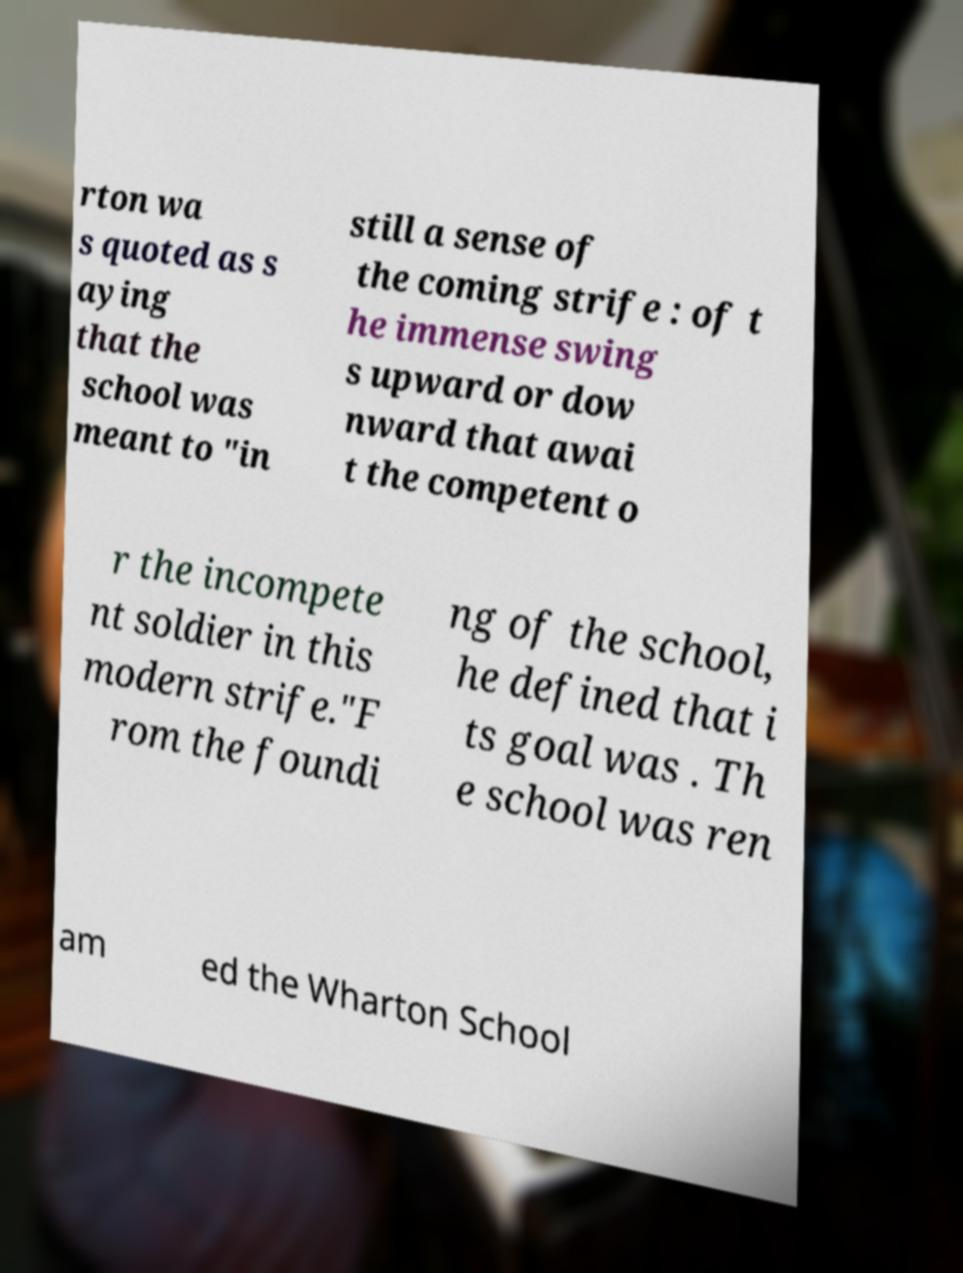Can you accurately transcribe the text from the provided image for me? rton wa s quoted as s aying that the school was meant to "in still a sense of the coming strife : of t he immense swing s upward or dow nward that awai t the competent o r the incompete nt soldier in this modern strife."F rom the foundi ng of the school, he defined that i ts goal was . Th e school was ren am ed the Wharton School 